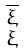Convert formula to latex. <formula><loc_0><loc_0><loc_500><loc_500>\begin{smallmatrix} \overline { \xi } \\ \xi \end{smallmatrix}</formula> 